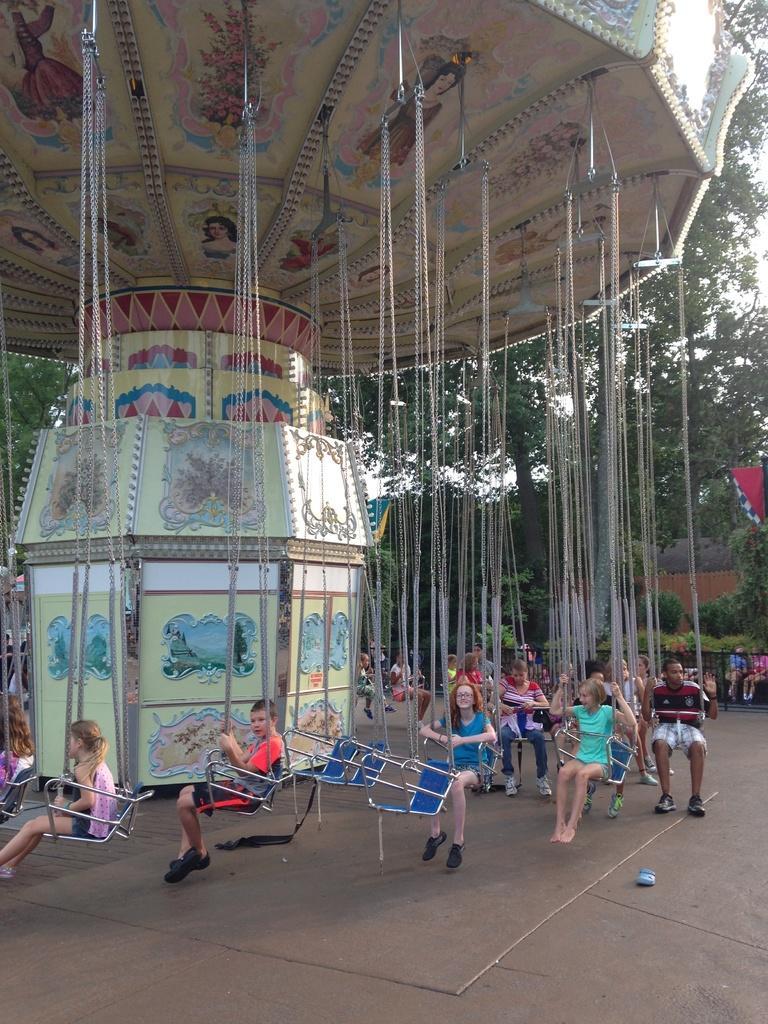Could you give a brief overview of what you see in this image? In this image we can see some group of kids who are sitting on the child carousel and at the background of the image there are some trees. 